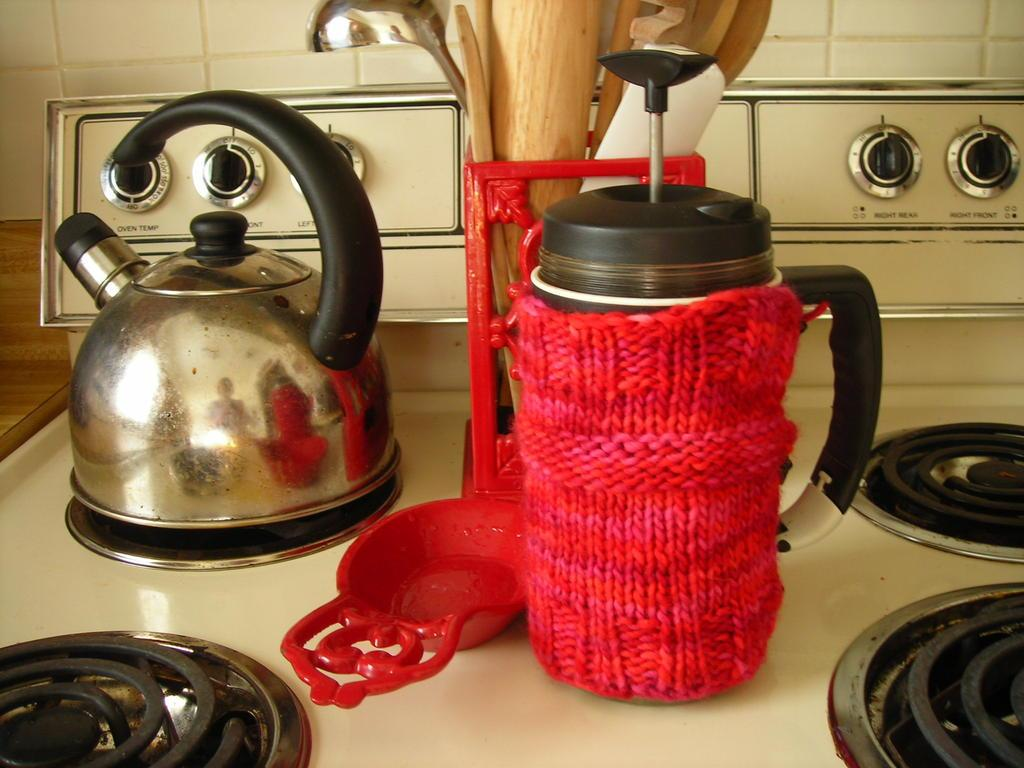<image>
Create a compact narrative representing the image presented. French press coffee mug wrapped in a warmer on the stove top with all dials turned to OFF. 